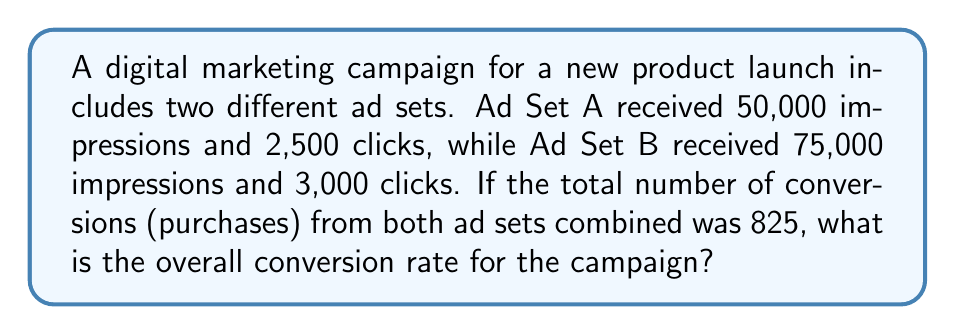Can you solve this math problem? To solve this problem, we need to follow these steps:

1. Calculate the Click-Through Rate (CTR) for each ad set:
   CTR = (Number of Clicks / Number of Impressions) × 100%

   Ad Set A: $CTR_A = \frac{2,500}{50,000} \times 100\% = 5\%$
   Ad Set B: $CTR_B = \frac{3,000}{75,000} \times 100\% = 4\%$

2. Calculate the total number of clicks:
   Total Clicks = Clicks from Ad Set A + Clicks from Ad Set B
   $Total Clicks = 2,500 + 3,000 = 5,500$

3. Calculate the overall Conversion Rate:
   Conversion Rate = (Number of Conversions / Total Clicks) × 100%

   $Conversion Rate = \frac{825}{5,500} \times 100\% = 15\%$

The overall conversion rate for the campaign is 15%.
Answer: 15% 